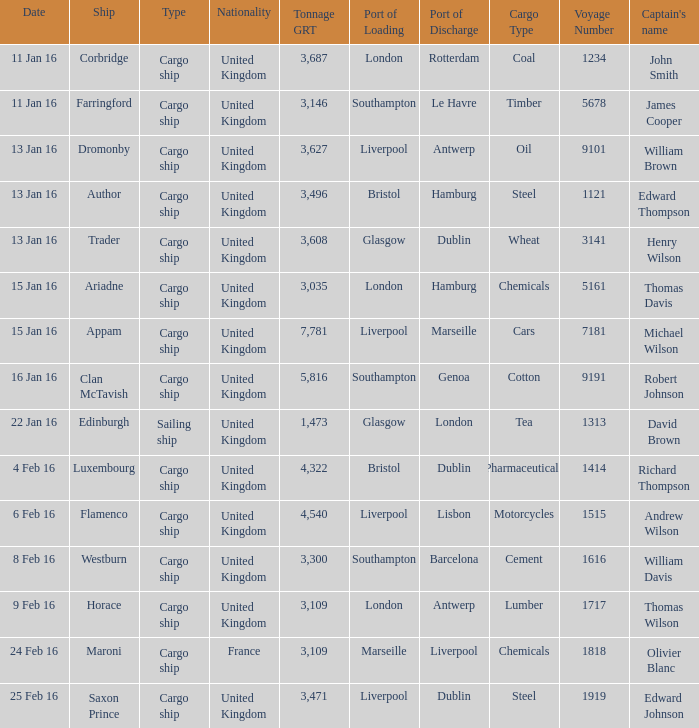What is the nationality of the ship appam? United Kingdom. 